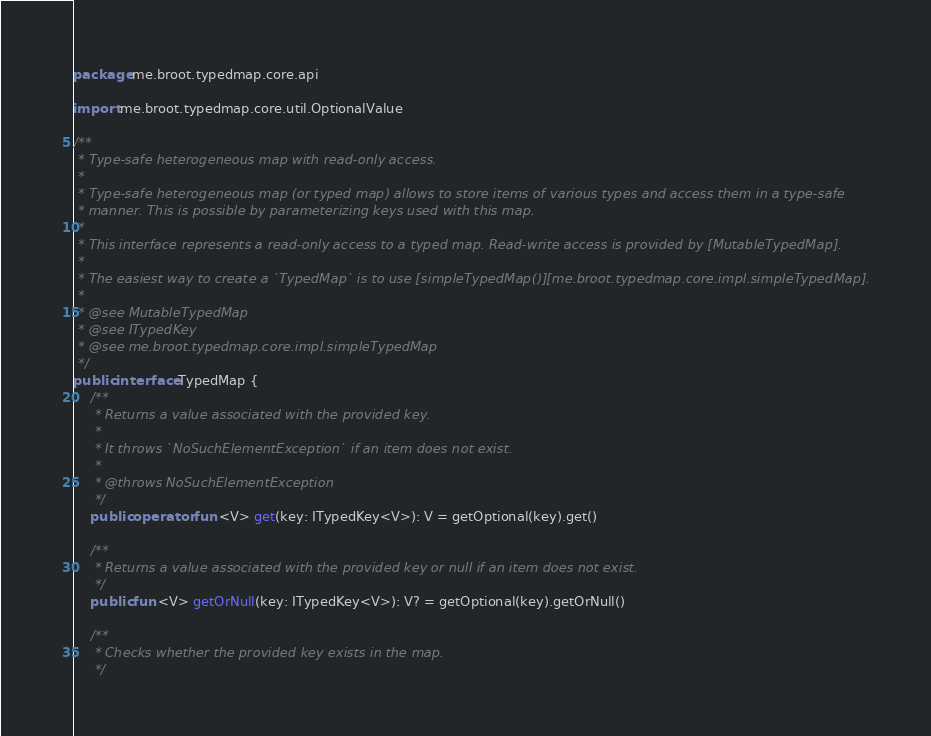Convert code to text. <code><loc_0><loc_0><loc_500><loc_500><_Kotlin_>package me.broot.typedmap.core.api

import me.broot.typedmap.core.util.OptionalValue

/**
 * Type-safe heterogeneous map with read-only access.
 *
 * Type-safe heterogeneous map (or typed map) allows to store items of various types and access them in a type-safe
 * manner. This is possible by parameterizing keys used with this map.
 *
 * This interface represents a read-only access to a typed map. Read-write access is provided by [MutableTypedMap].
 *
 * The easiest way to create a `TypedMap` is to use [simpleTypedMap()][me.broot.typedmap.core.impl.simpleTypedMap].
 *
 * @see MutableTypedMap
 * @see ITypedKey
 * @see me.broot.typedmap.core.impl.simpleTypedMap
 */
public interface TypedMap {
    /**
     * Returns a value associated with the provided key.
     *
     * It throws `NoSuchElementException` if an item does not exist.
     *
     * @throws NoSuchElementException
     */
    public operator fun <V> get(key: ITypedKey<V>): V = getOptional(key).get()

    /**
     * Returns a value associated with the provided key or null if an item does not exist.
     */
    public fun <V> getOrNull(key: ITypedKey<V>): V? = getOptional(key).getOrNull()

    /**
     * Checks whether the provided key exists in the map.
     */</code> 